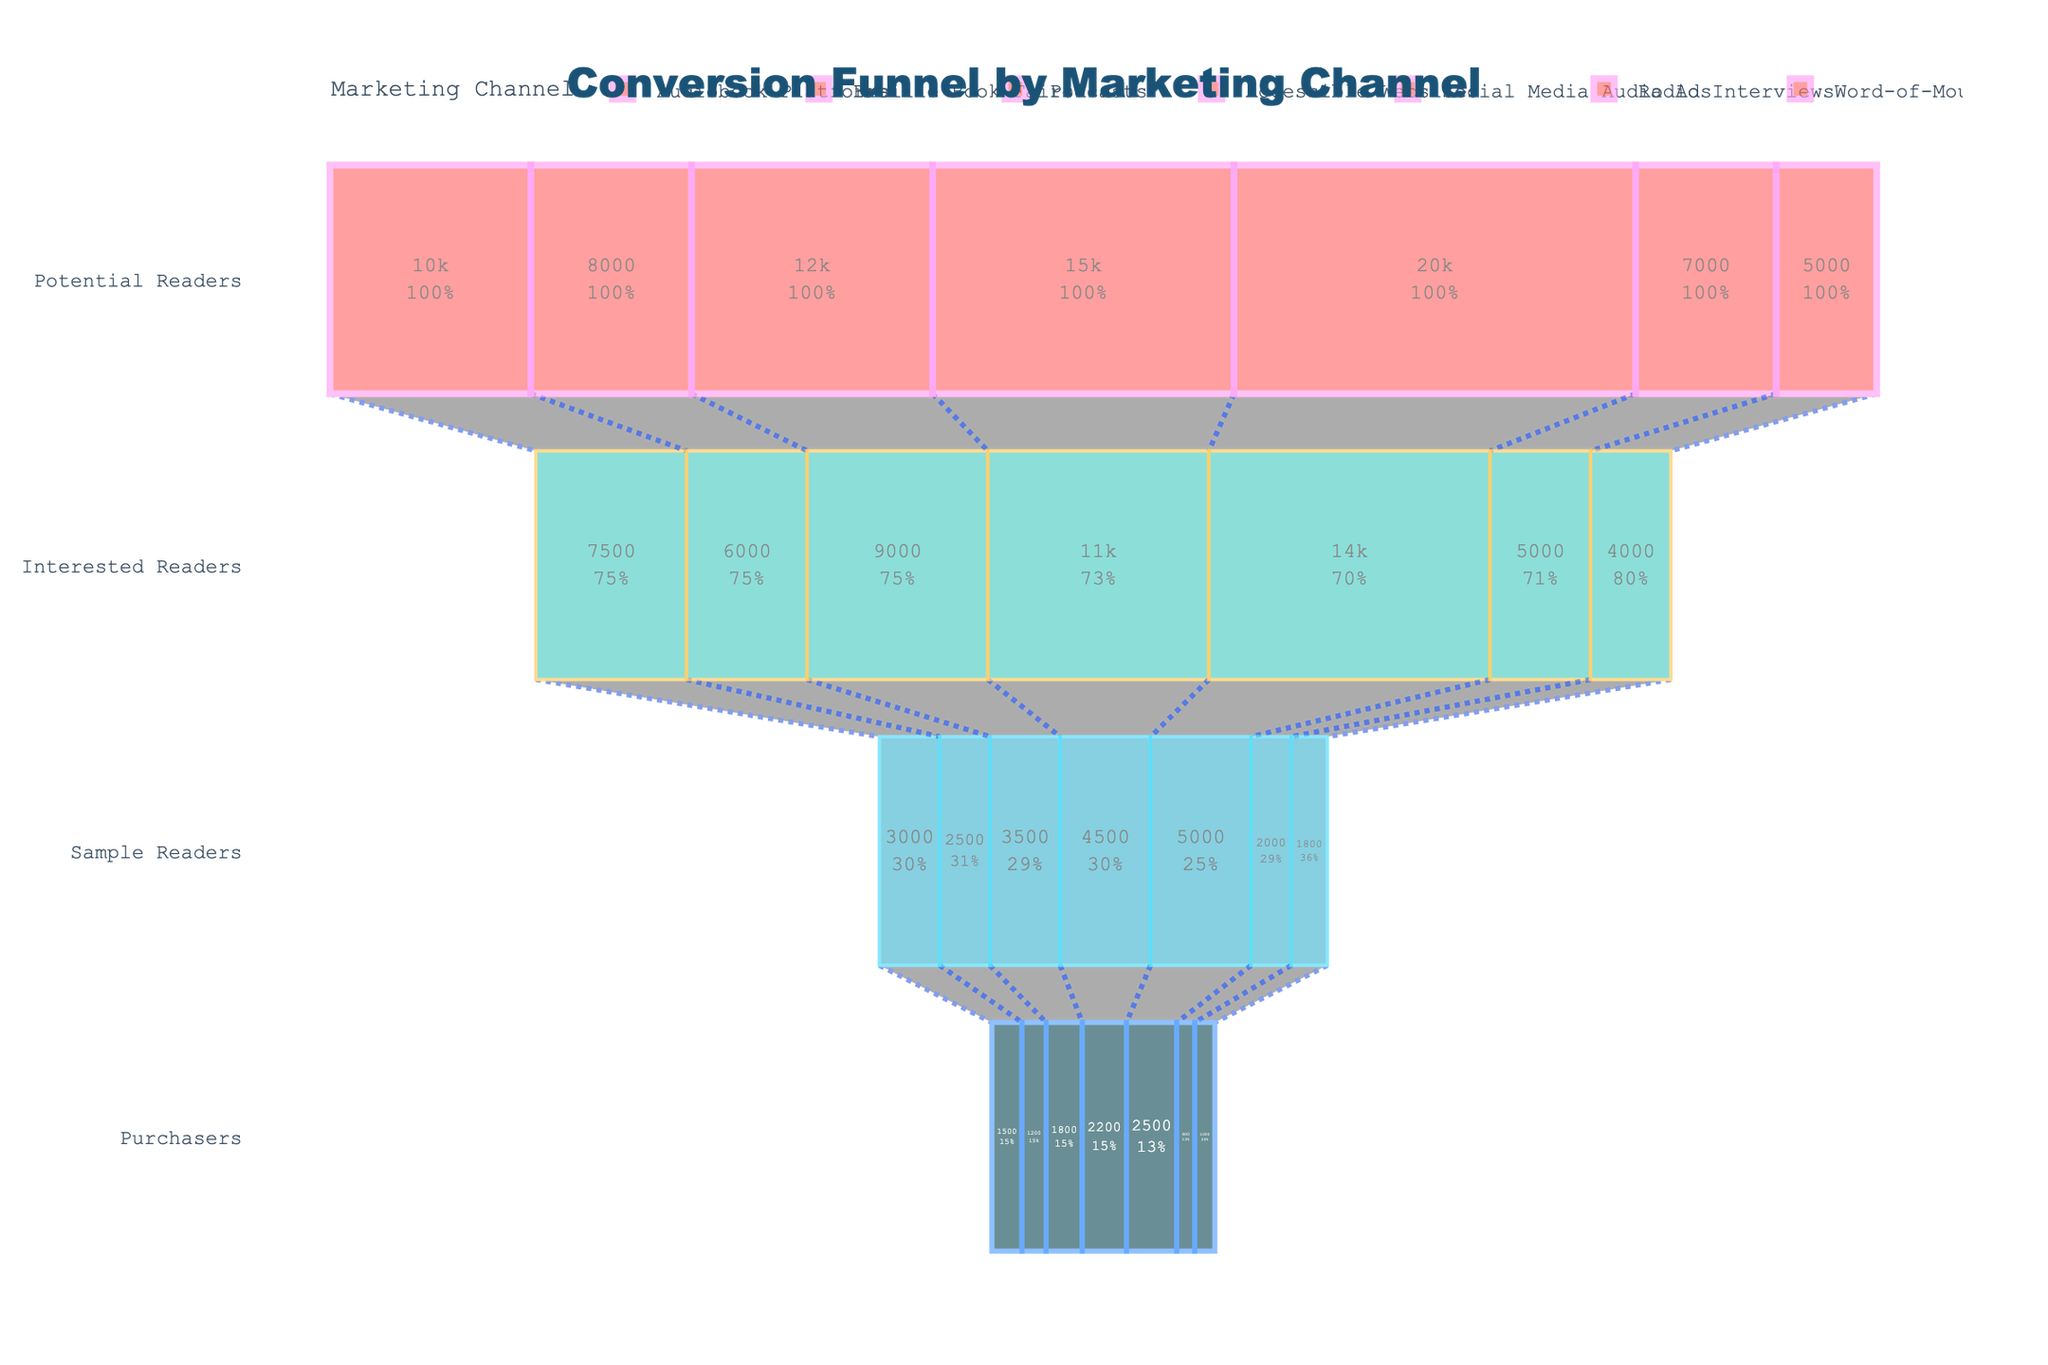What is the title of the figure? The title of the figure is prominently positioned at the top of the chart. It is styled differently to stand out, often using a larger font size or different color compared to other text in the chart.
Answer: Conversion Funnel by Marketing Channel How many marketing channels are represented in the chart? The funnel chart includes each channel as a separate trace or data series. You can identify the number of marketing channels by counting the number of different traces or legends in the figure.
Answer: Seven Which marketing channel has the highest number of potential readers? Look at the values for 'Potential Readers' at the top of the funnel for each channel. The channel with the largest value will have the highest number.
Answer: Social Media Audio Ads What is the difference in the number of purchasers between Accessible Websites and Audiobook Platforms? Find the 'Purchasers' values for both Accessible Websites and Audiobook Platforms and subtract the smaller value from the larger one to get the difference.
Answer: 700 Which channel has the highest conversion rate from Interested Readers to Sample Readers? Calculate the conversion rate by dividing the number of Sample Readers by the number of Interested Readers for each channel. The channel with the highest result has the highest conversion rate.
Answer: Social Media Audio Ads What percentage of potential readers from Radio Interviews became purchasers? To find the percentage, divide the number of purchasers by the number of potential readers in Radio Interviews and multiply by 100.
Answer: 12.86% Compare the number of Interested Readers between Podcasts and Word-of-Mouth. Which has more? Look at the values of 'Interested Readers' for Podcasts and Word-of-Mouth. The larger value indicates which channel has more interested readers.
Answer: Podcasts What's the average number of purchasers across all marketing channels? Add up the number of purchasers for all channels and divide by the number of channels to get the average.
Answer: 1446 Which stage shows the most significant drop in reader count for Braille Book Fairs? Compare the values between each transition stage for Braille Book Fairs to see where the biggest decrease occurs.
Answer: Sample Readers to Purchasers For which channel is the conversion from Sample Readers to Purchasers the lowest? Calculate the conversion rate by dividing the Purchasers by Sample Readers for each channel. The channel with the smallest result has the lowest conversion.
Answer: Braille Book Fairs 